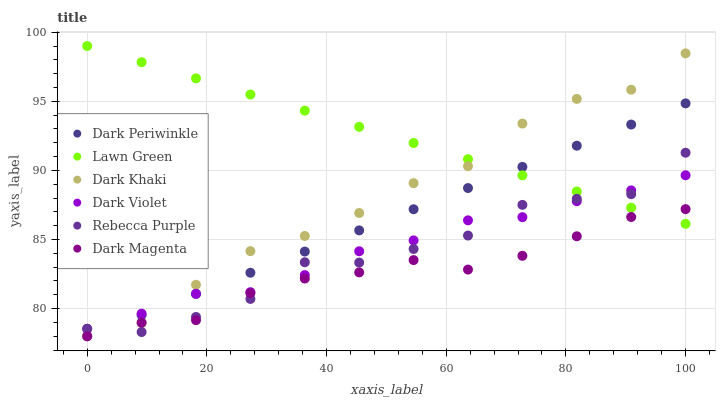Does Dark Magenta have the minimum area under the curve?
Answer yes or no. Yes. Does Lawn Green have the maximum area under the curve?
Answer yes or no. Yes. Does Dark Violet have the minimum area under the curve?
Answer yes or no. No. Does Dark Violet have the maximum area under the curve?
Answer yes or no. No. Is Dark Periwinkle the smoothest?
Answer yes or no. Yes. Is Rebecca Purple the roughest?
Answer yes or no. Yes. Is Dark Magenta the smoothest?
Answer yes or no. No. Is Dark Magenta the roughest?
Answer yes or no. No. Does Dark Magenta have the lowest value?
Answer yes or no. Yes. Does Dark Violet have the lowest value?
Answer yes or no. No. Does Lawn Green have the highest value?
Answer yes or no. Yes. Does Dark Violet have the highest value?
Answer yes or no. No. Is Dark Magenta less than Dark Violet?
Answer yes or no. Yes. Is Dark Violet greater than Dark Magenta?
Answer yes or no. Yes. Does Dark Magenta intersect Dark Khaki?
Answer yes or no. Yes. Is Dark Magenta less than Dark Khaki?
Answer yes or no. No. Is Dark Magenta greater than Dark Khaki?
Answer yes or no. No. Does Dark Magenta intersect Dark Violet?
Answer yes or no. No. 